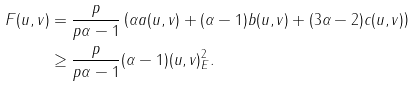Convert formula to latex. <formula><loc_0><loc_0><loc_500><loc_500>F ( u , v ) & = \frac { p } { p \alpha - 1 } \left ( \alpha a ( u , v ) + ( \alpha - 1 ) b ( u , v ) + ( 3 \alpha - 2 ) c ( u , v ) \right ) \\ & \geq \frac { p } { p \alpha - 1 } ( \alpha - 1 ) \| ( u , v ) \| _ { E } ^ { 2 } .</formula> 